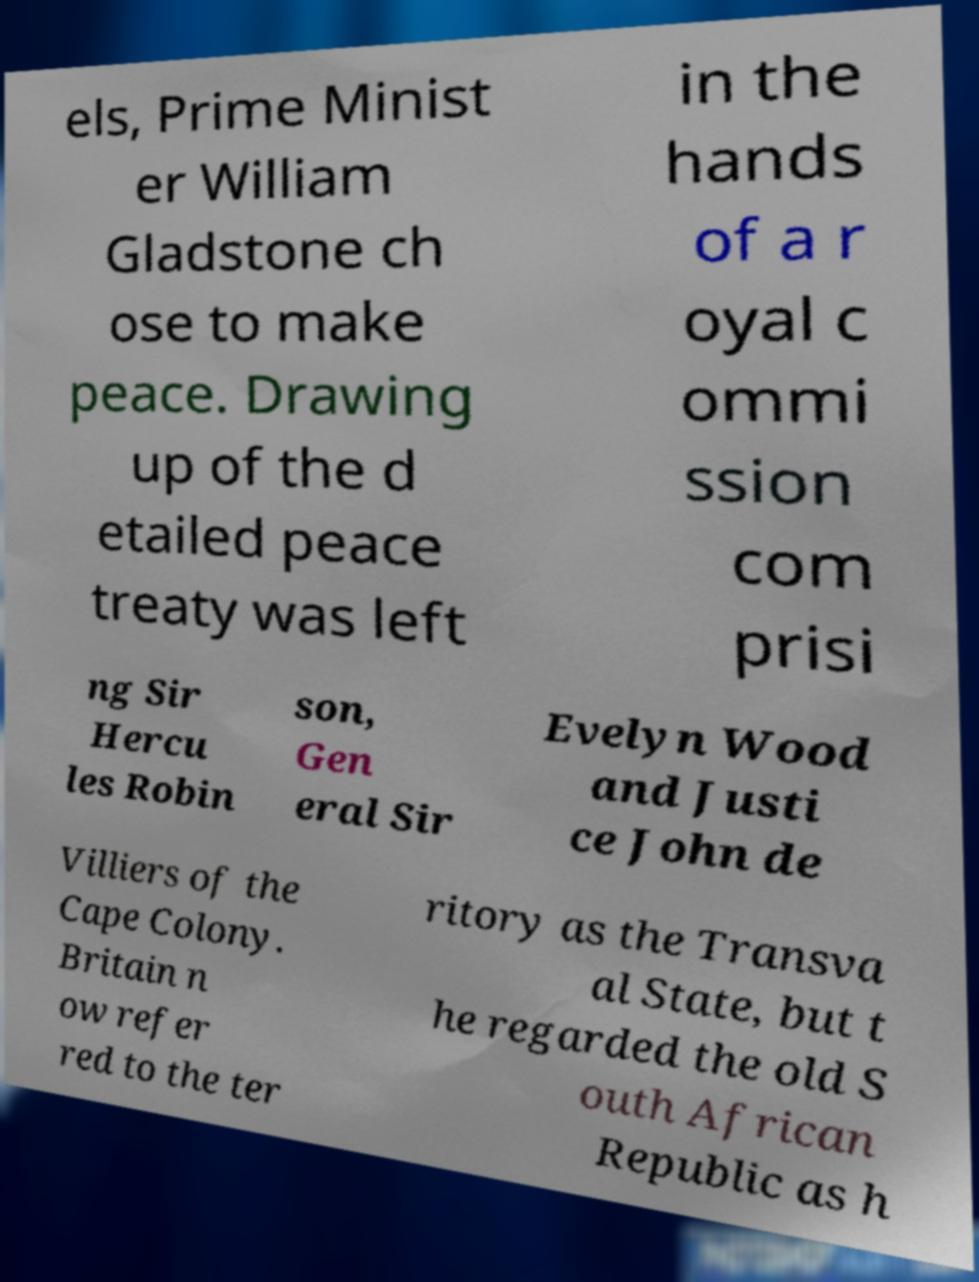Could you extract and type out the text from this image? els, Prime Minist er William Gladstone ch ose to make peace. Drawing up of the d etailed peace treaty was left in the hands of a r oyal c ommi ssion com prisi ng Sir Hercu les Robin son, Gen eral Sir Evelyn Wood and Justi ce John de Villiers of the Cape Colony. Britain n ow refer red to the ter ritory as the Transva al State, but t he regarded the old S outh African Republic as h 